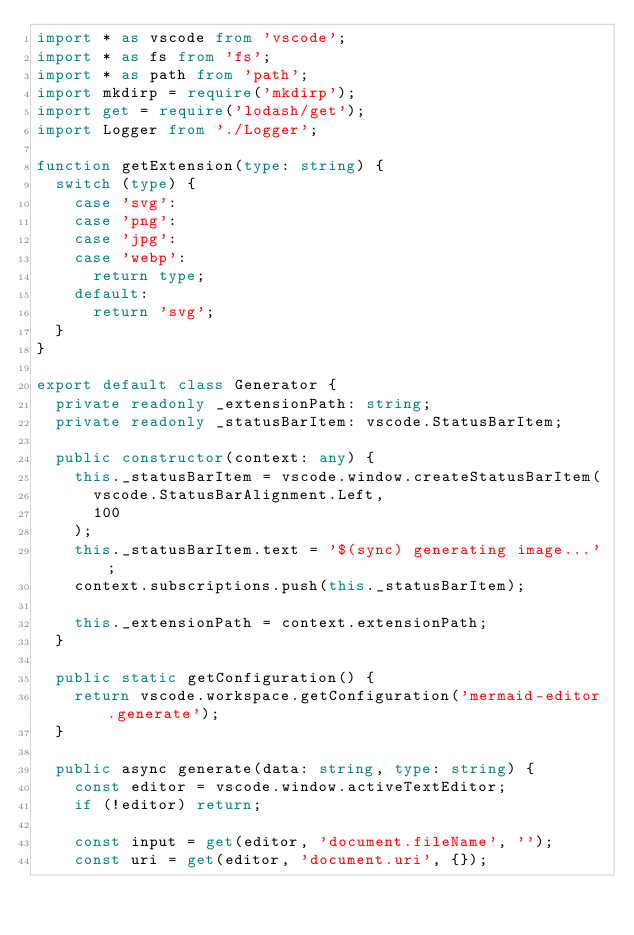<code> <loc_0><loc_0><loc_500><loc_500><_TypeScript_>import * as vscode from 'vscode';
import * as fs from 'fs';
import * as path from 'path';
import mkdirp = require('mkdirp');
import get = require('lodash/get');
import Logger from './Logger';

function getExtension(type: string) {
  switch (type) {
    case 'svg':
    case 'png':
    case 'jpg':
    case 'webp':
      return type;
    default:
      return 'svg';
  }
}

export default class Generator {
  private readonly _extensionPath: string;
  private readonly _statusBarItem: vscode.StatusBarItem;

  public constructor(context: any) {
    this._statusBarItem = vscode.window.createStatusBarItem(
      vscode.StatusBarAlignment.Left,
      100
    );
    this._statusBarItem.text = '$(sync) generating image...';
    context.subscriptions.push(this._statusBarItem);

    this._extensionPath = context.extensionPath;
  }

  public static getConfiguration() {
    return vscode.workspace.getConfiguration('mermaid-editor.generate');
  }

  public async generate(data: string, type: string) {
    const editor = vscode.window.activeTextEditor;
    if (!editor) return;

    const input = get(editor, 'document.fileName', '');
    const uri = get(editor, 'document.uri', {});</code> 